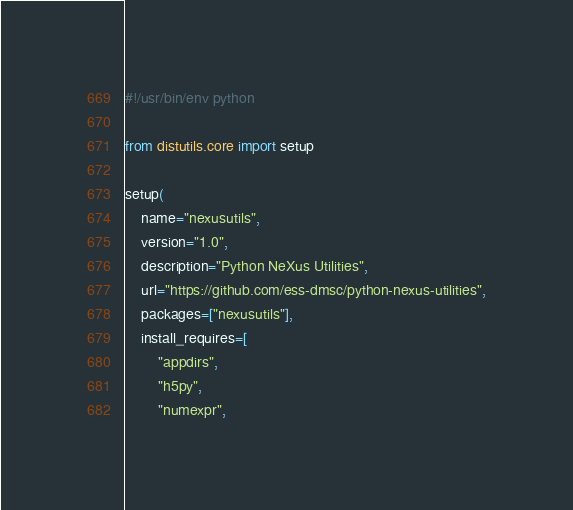<code> <loc_0><loc_0><loc_500><loc_500><_Python_>#!/usr/bin/env python

from distutils.core import setup

setup(
    name="nexusutils",
    version="1.0",
    description="Python NeXus Utilities",
    url="https://github.com/ess-dmsc/python-nexus-utilities",
    packages=["nexusutils"],
    install_requires=[
        "appdirs",
        "h5py",
        "numexpr",</code> 